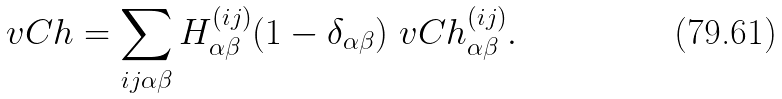<formula> <loc_0><loc_0><loc_500><loc_500>\ v C h = \sum _ { i j \alpha \beta } H ^ { ( i j ) } _ { \alpha \beta } ( 1 - \delta _ { \alpha \beta } ) \ v C h ^ { ( i j ) } _ { \alpha \beta } .</formula> 